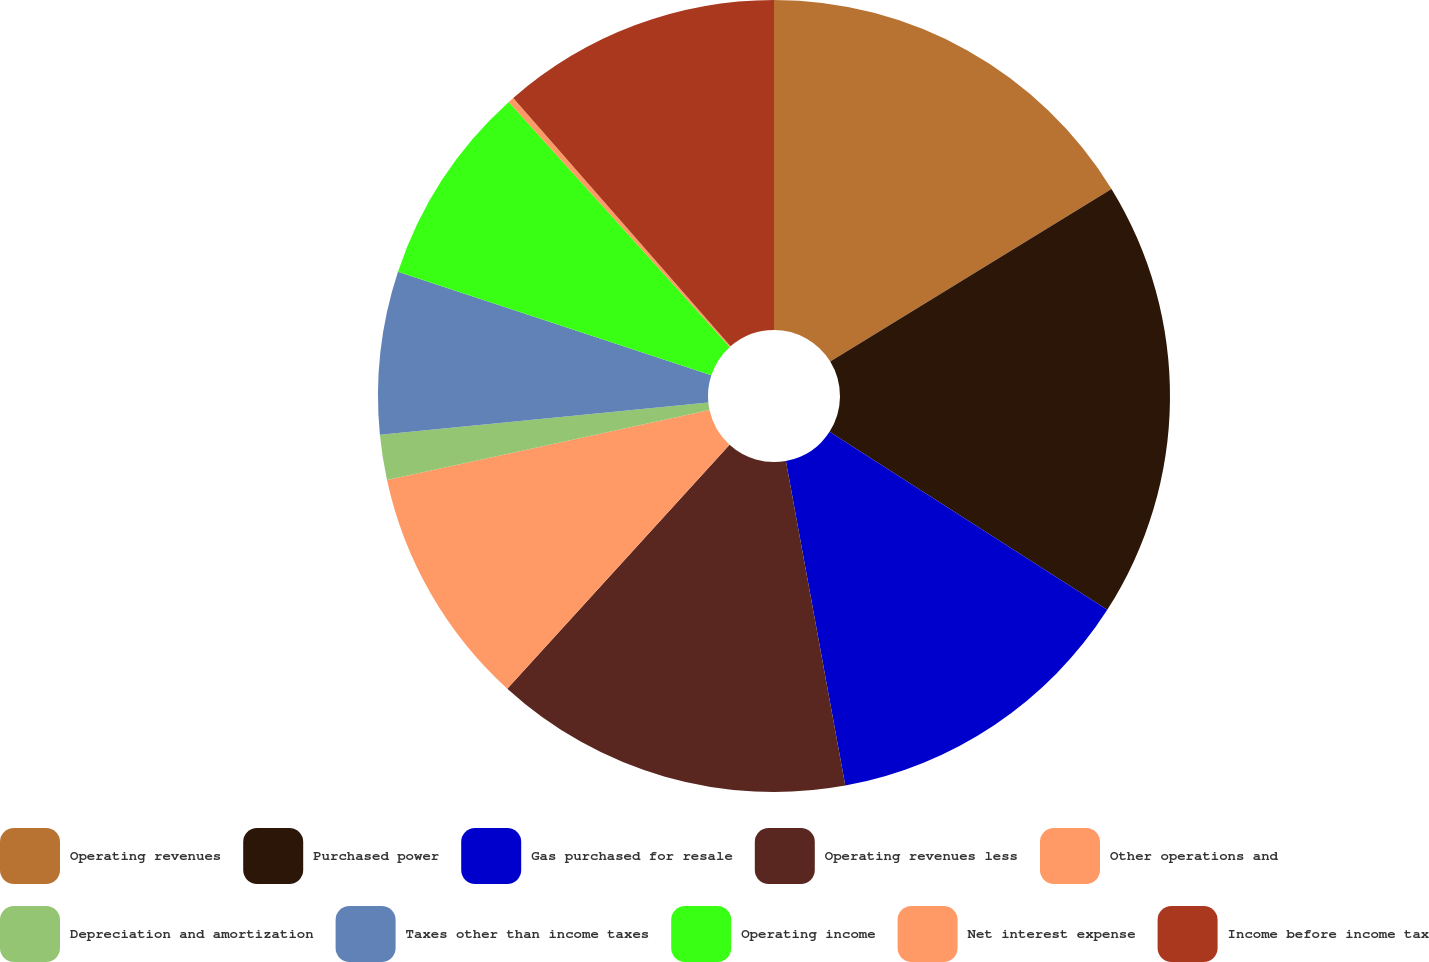Convert chart. <chart><loc_0><loc_0><loc_500><loc_500><pie_chart><fcel>Operating revenues<fcel>Purchased power<fcel>Gas purchased for resale<fcel>Operating revenues less<fcel>Other operations and<fcel>Depreciation and amortization<fcel>Taxes other than income taxes<fcel>Operating income<fcel>Net interest expense<fcel>Income before income tax<nl><fcel>16.24%<fcel>17.84%<fcel>13.04%<fcel>14.64%<fcel>9.84%<fcel>1.84%<fcel>6.64%<fcel>8.24%<fcel>0.24%<fcel>11.44%<nl></chart> 